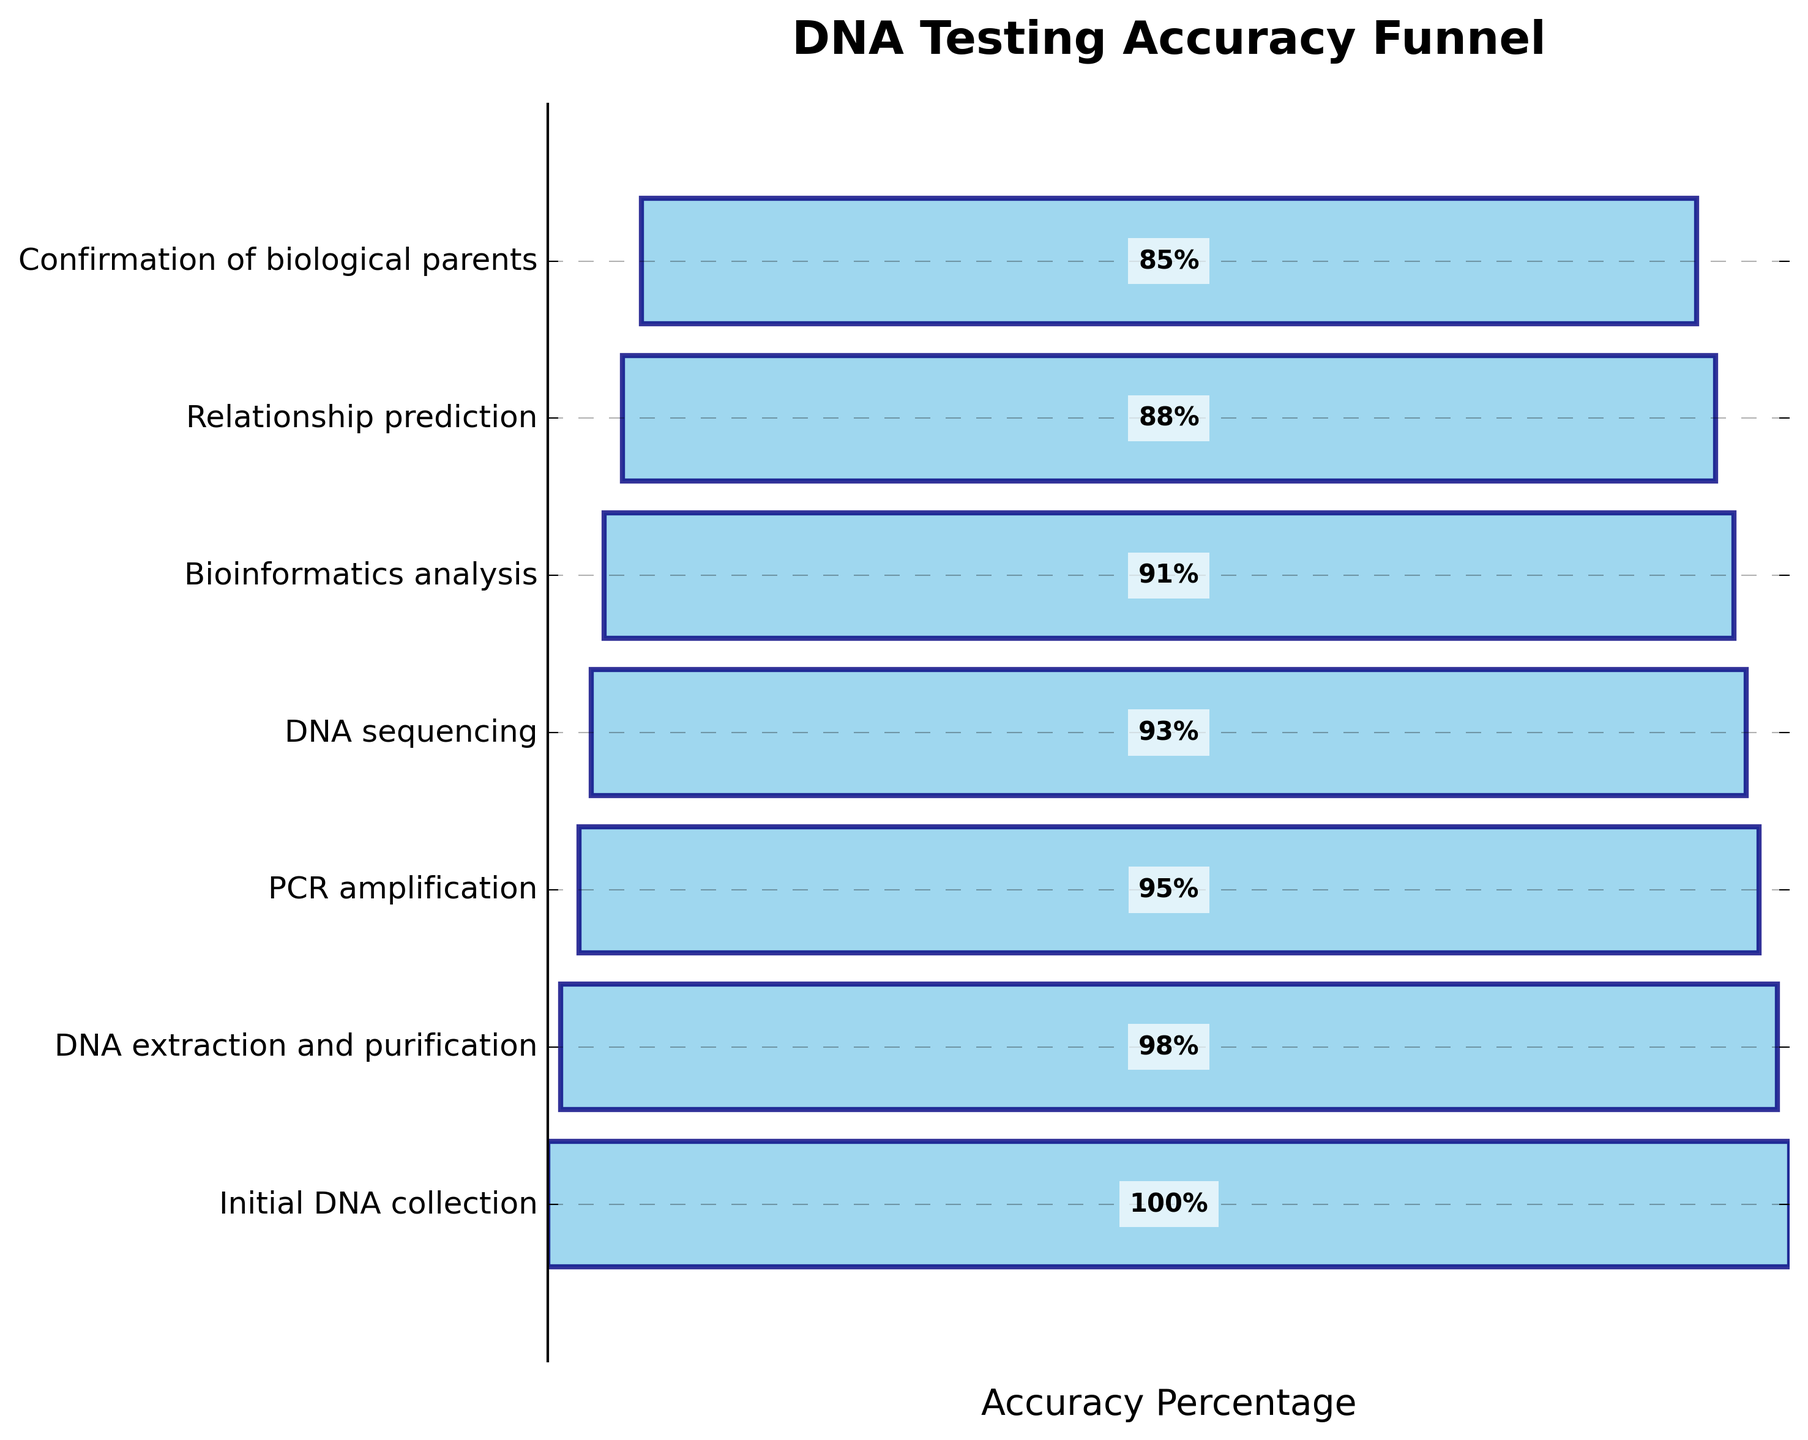what is the title of the funnel chart? The title of the funnel chart is displayed prominently at the top of the figure.
Answer: DNA Testing Accuracy Funnel What is the highest accuracy percentage shown on the chart? The highest accuracy percentage is the top value in the funnel and appears on the chart with the number 100 next to it.
Answer: 100% What is the accuracy percentage at the Bioinformatics analysis stage? Locate the Bioinformatics analysis stage on the y-axis and refer to its associated accuracy percentage on the chart.
Answer: 91% Which stage shows the largest drop in accuracy percentage from the previous stage? Compare the differences in accuracy percentages between each consecutive stage along the y-axis. The largest drop is the greatest numerical difference.
Answer: Relationship prediction How many stages are depicted in the funnel chart? Count the number of stages listed along the y-axis of the funnel chart.
Answer: 7 What is the average accuracy percentage for the entire process? Sum the accuracy percentages for all stages and divide by the total number of stages, which is 7. Calculations: (100 + 98 + 95 + 93 + 91 + 88 + 85) / 7 = 92.86
Answer: 92.86% Which two stages have the closest accuracy percentages? Examine each pair of consecutive accuracy percentages and determine which pair has the smallest numerical difference.
Answer: Bioinformatics analysis and Relationship prediction What is the percentage difference between DNA extraction and purification and PCR amplification stages? Subtract the accuracy percentage of the PCR amplification stage from the DNA extraction and purification stage. Calculation: 98 - 95 = 3
Answer: 3% Is the accuracy percentage greater at the Relationship prediction stage or at the Confirmation of biological parents stage? Compare the accuracy percentages at both stages from the y-axis labels.
Answer: Relationship prediction What is the overall decline in accuracy percentage from the Initial DNA collection to the Confirmation of biological parents stage? Subtract the accuracy percentage at the final stage from the initial stage. Calculation: 100 - 85 = 15
Answer: 15% 